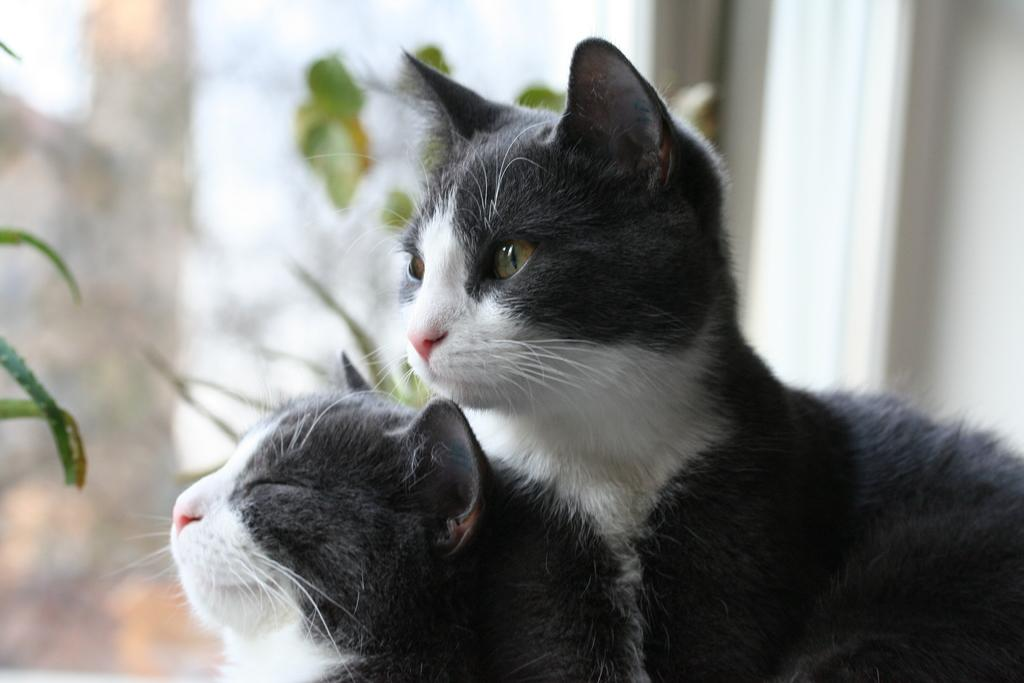How many cats are in the image? There are two cats in the image. What are the cats doing in the image? The cats are sitting. What colors are the cats in the image? The cats are black and white in color. What else can be seen in the image besides the cats? There are plants visible in the image. How would you describe the quality of the image? The image is slightly blurry in the background. How many horses are visible in the image? There are no horses present in the image. What type of sponge is being used by the cats in the image? There is no sponge present in the image, and the cats are not using any objects. 